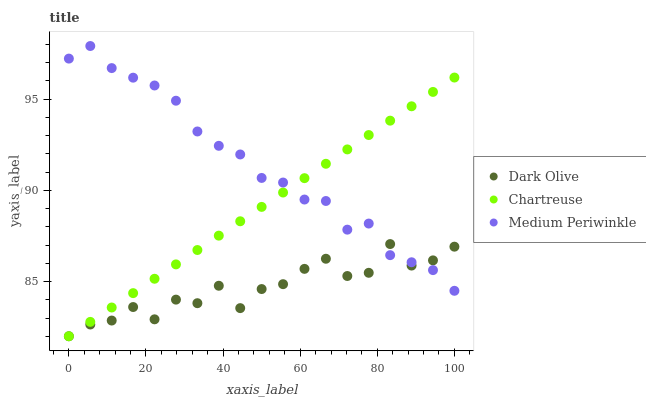Does Dark Olive have the minimum area under the curve?
Answer yes or no. Yes. Does Medium Periwinkle have the maximum area under the curve?
Answer yes or no. Yes. Does Medium Periwinkle have the minimum area under the curve?
Answer yes or no. No. Does Dark Olive have the maximum area under the curve?
Answer yes or no. No. Is Chartreuse the smoothest?
Answer yes or no. Yes. Is Dark Olive the roughest?
Answer yes or no. Yes. Is Medium Periwinkle the smoothest?
Answer yes or no. No. Is Medium Periwinkle the roughest?
Answer yes or no. No. Does Chartreuse have the lowest value?
Answer yes or no. Yes. Does Medium Periwinkle have the lowest value?
Answer yes or no. No. Does Medium Periwinkle have the highest value?
Answer yes or no. Yes. Does Dark Olive have the highest value?
Answer yes or no. No. Does Medium Periwinkle intersect Chartreuse?
Answer yes or no. Yes. Is Medium Periwinkle less than Chartreuse?
Answer yes or no. No. Is Medium Periwinkle greater than Chartreuse?
Answer yes or no. No. 